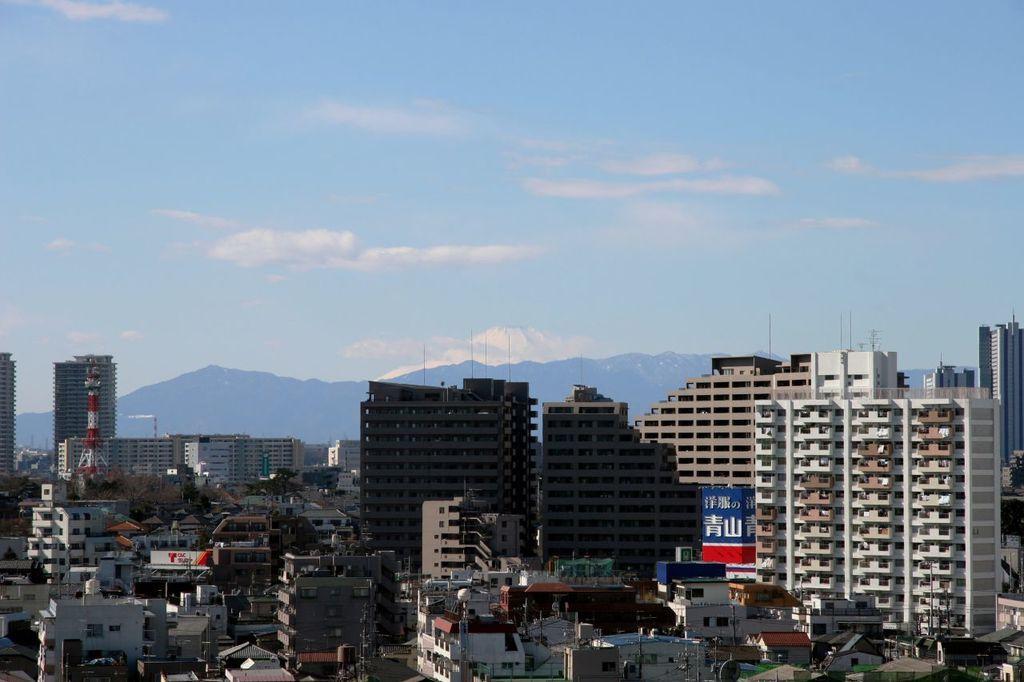In one or two sentences, can you explain what this image depicts? In this image I can see few buildings, they are in cream, white and brown color. Background I can see mountains and the sky is in blue and white color. 